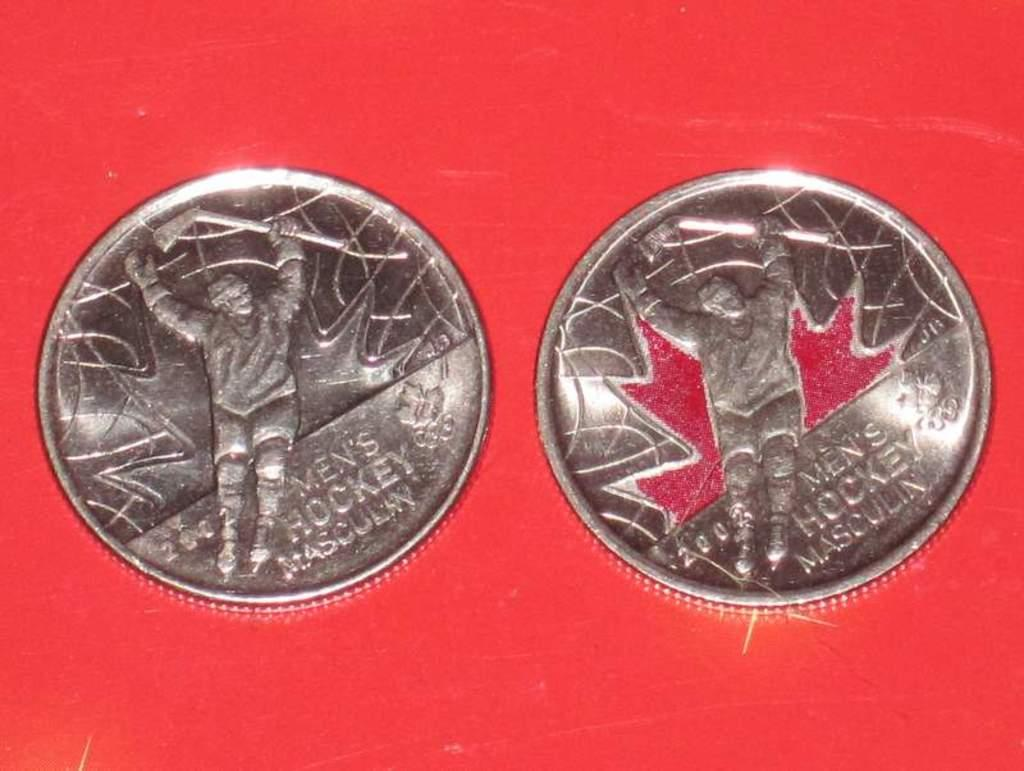<image>
Create a compact narrative representing the image presented. Two silver coins sitting on a red background with the number 200 on them. 